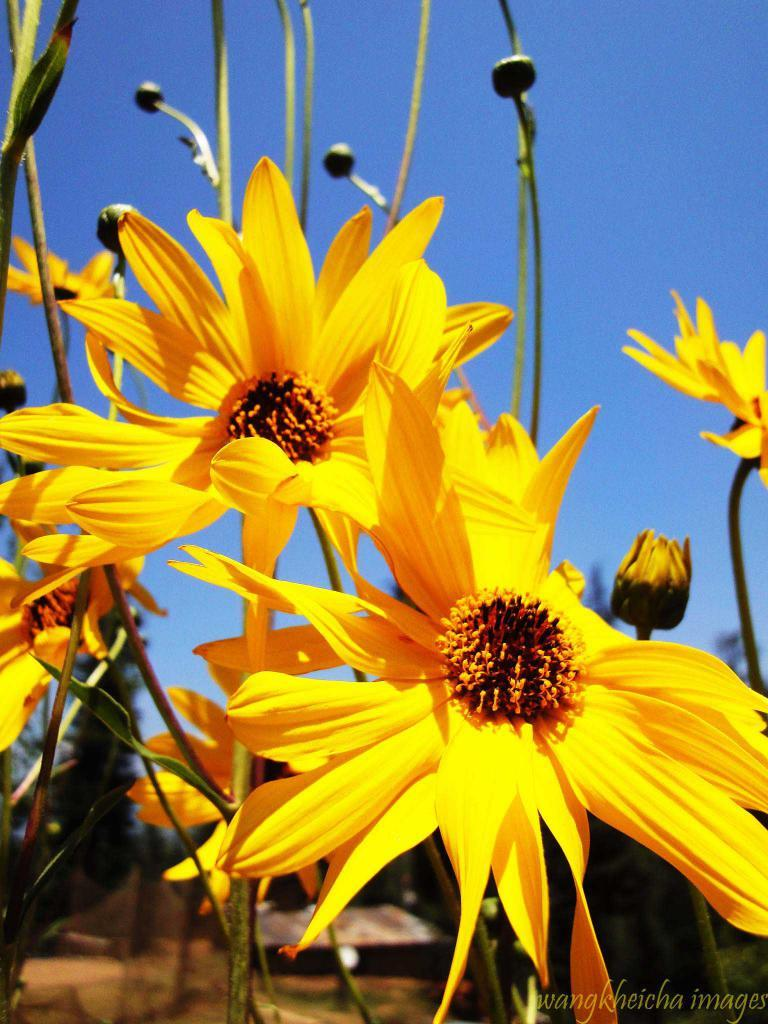What type of plants can be seen in the image? There are flowers in the image. Can you describe the stage of growth of some of the plants? Yes, there are buds in the image. What can be seen in the distance in the image? The sky is visible in the background of the image. Is there any additional information or marking on the image? Yes, there is a watermark on the image. What type of brass instrument is being played by the bear in the image? There is no brass instrument or bear present in the image; it features flowers and buds. 